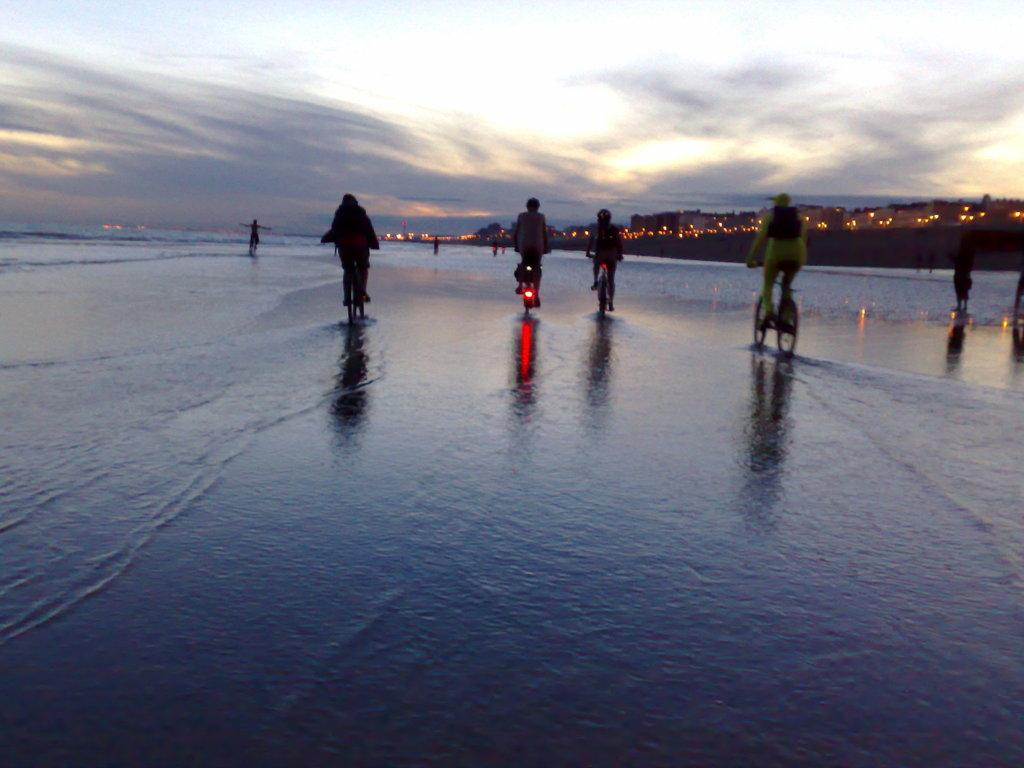What are the people in the image doing? The people in the image are riding bicycles. What can be seen in the foreground of the image? There is water visible in the image. What is visible in the background of the image? There are buildings, lights, and the sky visible in the background of the image. What type of riddle can be solved by looking at the floor in the image? There is no riddle present in the image, nor is there any mention of a floor. How much profit can be made from the bicycles in the image? There is no indication of profit or any financial aspect related to the bicycles in the image. 